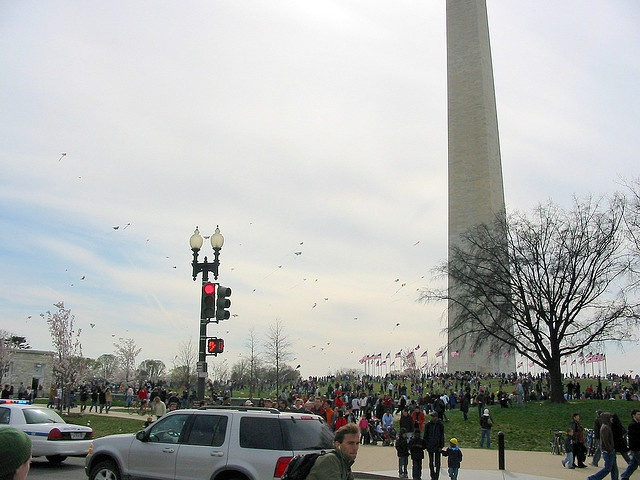Describe the objects in this image and their specific colors. I can see people in lightgray, black, gray, darkgreen, and darkgray tones, car in lightgray, black, and gray tones, car in lightgray, darkgray, gray, and black tones, people in lightgray, black, gray, and maroon tones, and kite in lightgray, darkgray, and lightblue tones in this image. 